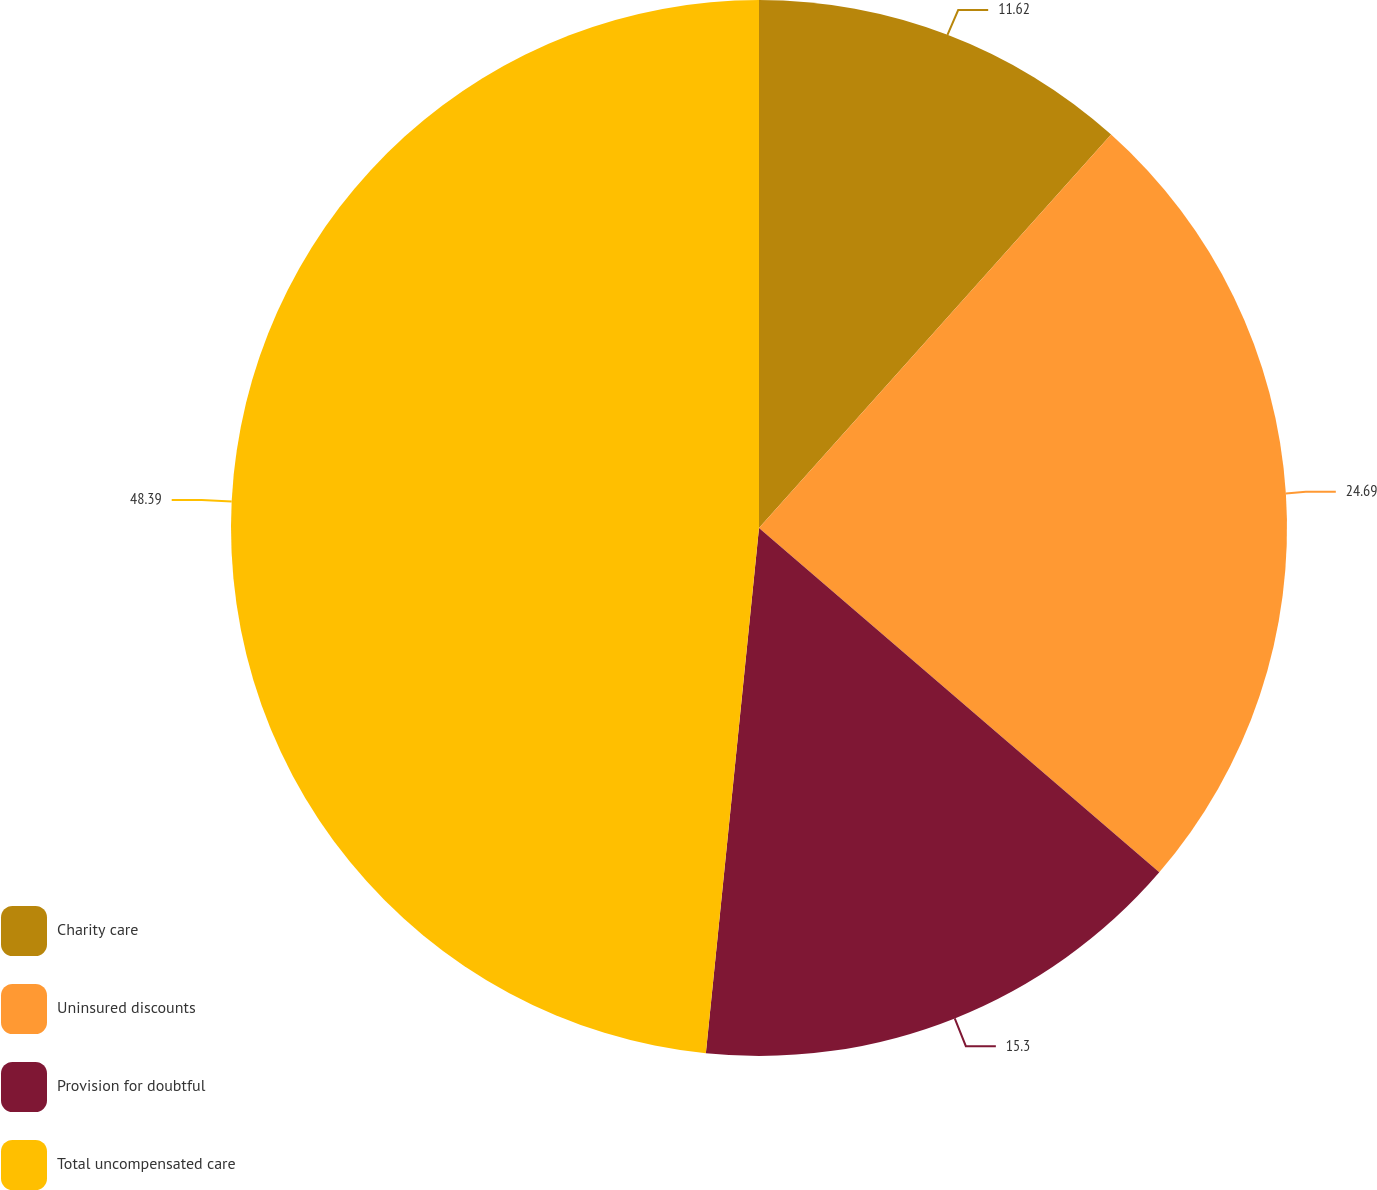Convert chart. <chart><loc_0><loc_0><loc_500><loc_500><pie_chart><fcel>Charity care<fcel>Uninsured discounts<fcel>Provision for doubtful<fcel>Total uncompensated care<nl><fcel>11.62%<fcel>24.69%<fcel>15.3%<fcel>48.4%<nl></chart> 